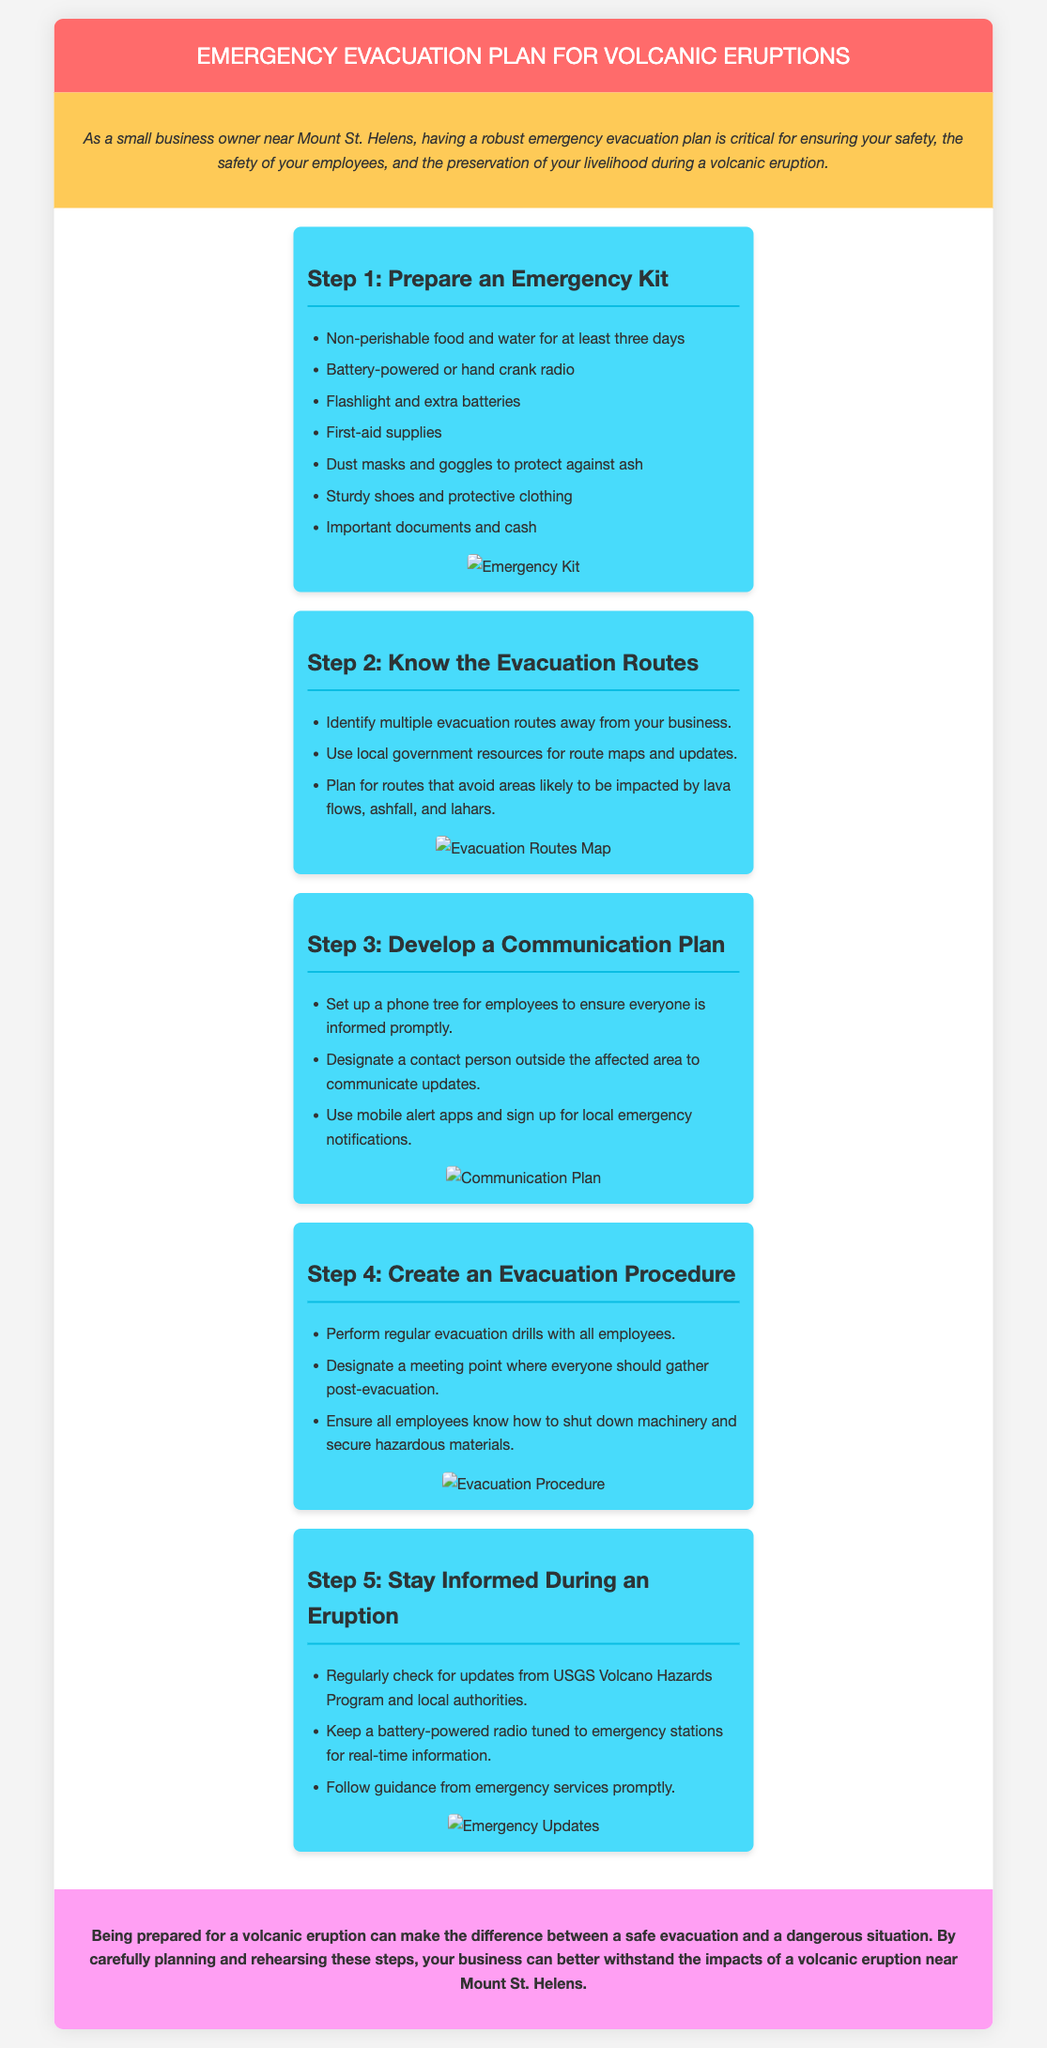What is the title of the document? The title of the document is prominently displayed in the header section.
Answer: Emergency Evacuation Plan for Volcanic Eruptions How many steps are outlined in the evacuation plan? The document indicates a total of five distinct steps in the evacuation plan.
Answer: 5 What should be included in the emergency kit? The document lists several essential items needed in the emergency kit.
Answer: Non-perishable food and water for at least three days Which organization provides updates during an eruption? The document names a specific organization responsible for updates about volcanic activity.
Answer: USGS Volcano Hazards Program What is the purpose of a communication plan? The document describes the purpose of having a communication plan as a way to inform employees.
Answer: Ensure everyone is informed promptly What should you do with machinery during evacuation? The document specifies a critical action regarding machinery for employee safety during an evacuation.
Answer: Shut down machinery and secure hazardous materials How often should evacuation drills be performed? The document suggests the regular frequency of evacuation drills for preparedness.
Answer: Regularly What type of radio should be kept for emergency updates? The document specifies the kind of radio that should be included in your emergency supplies for updates.
Answer: Battery-powered or hand-crank radio 